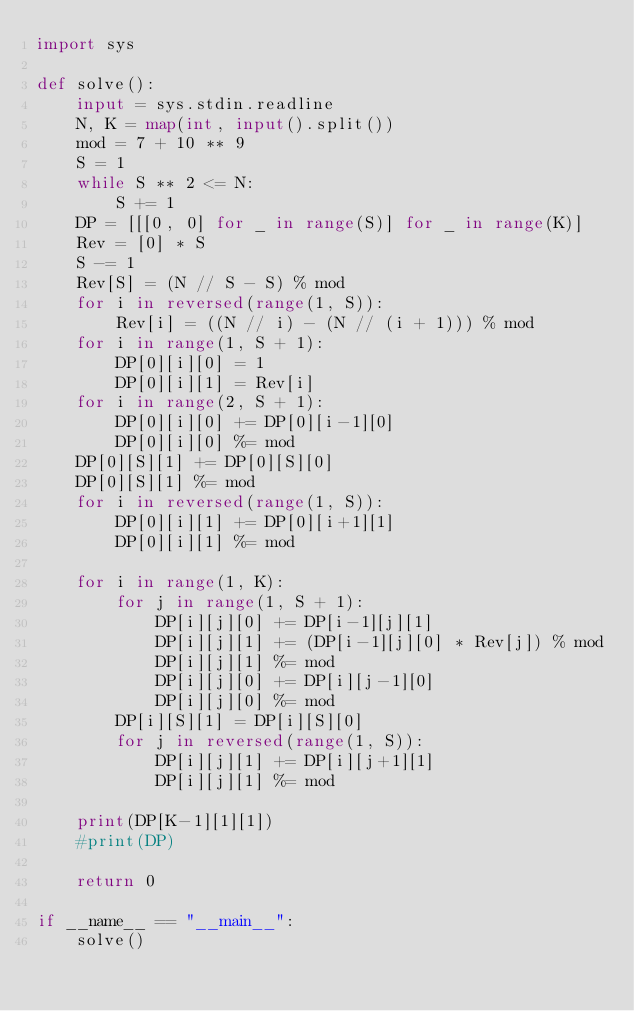<code> <loc_0><loc_0><loc_500><loc_500><_Python_>import sys

def solve():
    input = sys.stdin.readline
    N, K = map(int, input().split())
    mod = 7 + 10 ** 9
    S = 1
    while S ** 2 <= N:
        S += 1
    DP = [[[0, 0] for _ in range(S)] for _ in range(K)]
    Rev = [0] * S
    S -= 1
    Rev[S] = (N // S - S) % mod
    for i in reversed(range(1, S)):
        Rev[i] = ((N // i) - (N // (i + 1))) % mod
    for i in range(1, S + 1):
        DP[0][i][0] = 1
        DP[0][i][1] = Rev[i]
    for i in range(2, S + 1):
        DP[0][i][0] += DP[0][i-1][0]
        DP[0][i][0] %= mod
    DP[0][S][1] += DP[0][S][0]
    DP[0][S][1] %= mod
    for i in reversed(range(1, S)):
        DP[0][i][1] += DP[0][i+1][1]
        DP[0][i][1] %= mod

    for i in range(1, K):
        for j in range(1, S + 1):
            DP[i][j][0] += DP[i-1][j][1]
            DP[i][j][1] += (DP[i-1][j][0] * Rev[j]) % mod
            DP[i][j][1] %= mod
            DP[i][j][0] += DP[i][j-1][0]
            DP[i][j][0] %= mod
        DP[i][S][1] = DP[i][S][0]
        for j in reversed(range(1, S)):
            DP[i][j][1] += DP[i][j+1][1]
            DP[i][j][1] %= mod

    print(DP[K-1][1][1])
    #print(DP)

    return 0

if __name__ == "__main__":
    solve()</code> 